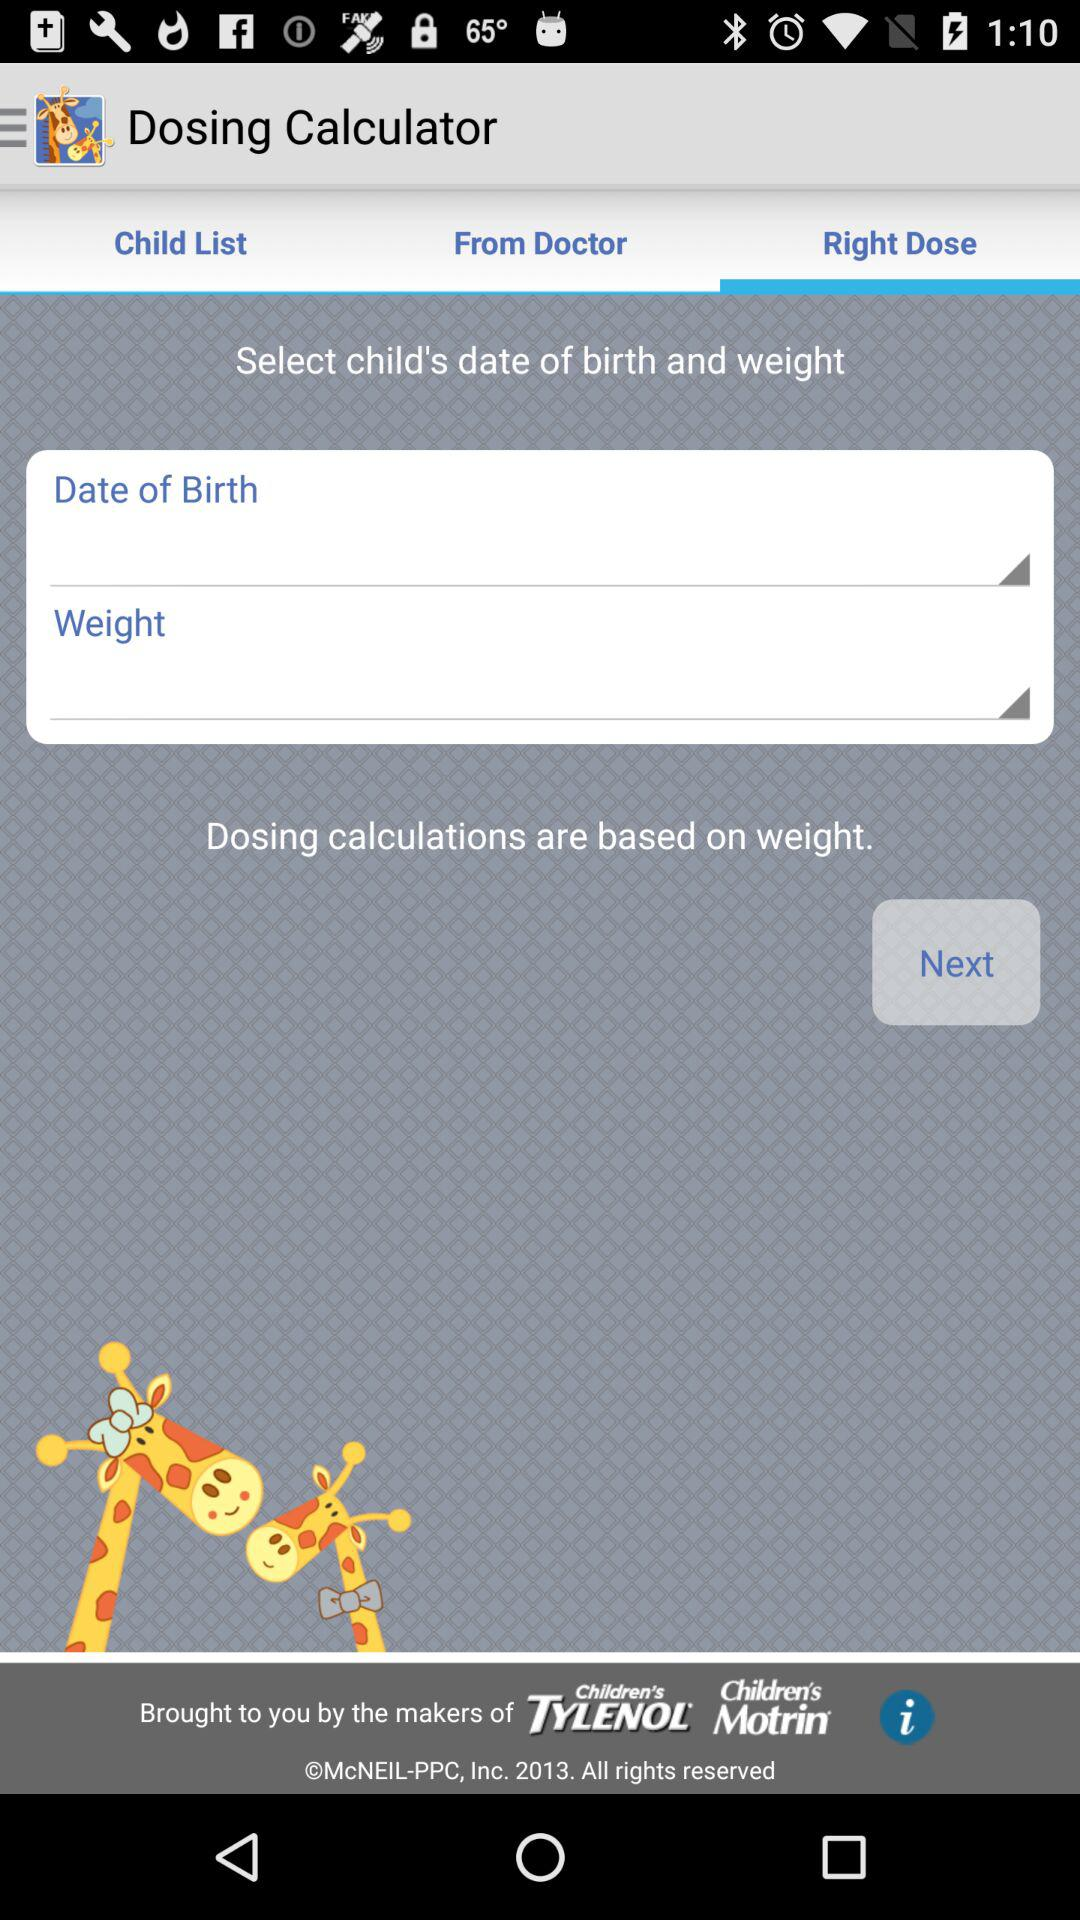Which tab has been selected? The tab that has been selected is "Right Dose". 